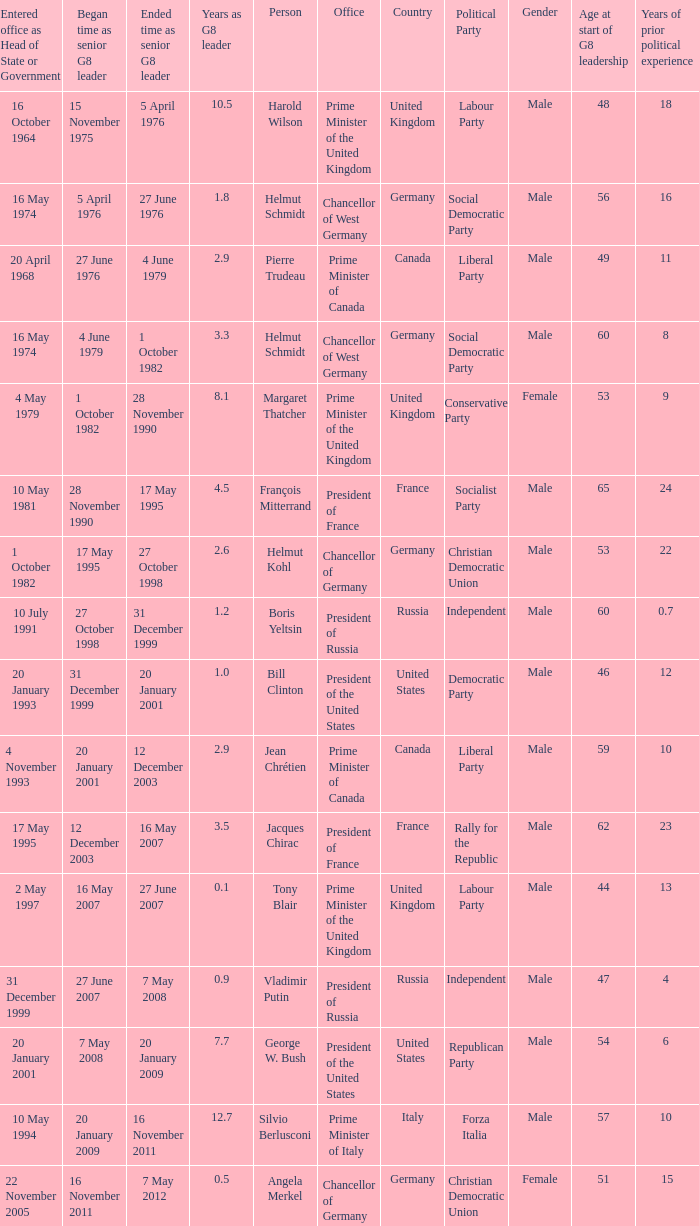When did the Prime Minister of Italy take office? 10 May 1994. Give me the full table as a dictionary. {'header': ['Entered office as Head of State or Government', 'Began time as senior G8 leader', 'Ended time as senior G8 leader', 'Years as G8 leader', 'Person', 'Office', 'Country', 'Political Party', 'Gender', 'Age at start of G8 leadership', 'Years of prior political experience '], 'rows': [['16 October 1964', '15 November 1975', '5 April 1976', '10.5', 'Harold Wilson', 'Prime Minister of the United Kingdom', 'United Kingdom', 'Labour Party', 'Male', '48', '18 '], ['16 May 1974', '5 April 1976', '27 June 1976', '1.8', 'Helmut Schmidt', 'Chancellor of West Germany', 'Germany', 'Social Democratic Party', 'Male', '56', '16 '], ['20 April 1968', '27 June 1976', '4 June 1979', '2.9', 'Pierre Trudeau', 'Prime Minister of Canada', 'Canada', 'Liberal Party', 'Male', '49', '11 '], ['16 May 1974', '4 June 1979', '1 October 1982', '3.3', 'Helmut Schmidt', 'Chancellor of West Germany', 'Germany', 'Social Democratic Party', 'Male', '60', '8 '], ['4 May 1979', '1 October 1982', '28 November 1990', '8.1', 'Margaret Thatcher', 'Prime Minister of the United Kingdom', 'United Kingdom', 'Conservative Party', 'Female', '53', '9 '], ['10 May 1981', '28 November 1990', '17 May 1995', '4.5', 'François Mitterrand', 'President of France', 'France', 'Socialist Party', 'Male', '65', '24 '], ['1 October 1982', '17 May 1995', '27 October 1998', '2.6', 'Helmut Kohl', 'Chancellor of Germany', 'Germany', 'Christian Democratic Union', 'Male', '53', '22 '], ['10 July 1991', '27 October 1998', '31 December 1999', '1.2', 'Boris Yeltsin', 'President of Russia', 'Russia', 'Independent', 'Male', '60', '0.7 '], ['20 January 1993', '31 December 1999', '20 January 2001', '1.0', 'Bill Clinton', 'President of the United States', 'United States', 'Democratic Party', 'Male', '46', '12 '], ['4 November 1993', '20 January 2001', '12 December 2003', '2.9', 'Jean Chrétien', 'Prime Minister of Canada', 'Canada', 'Liberal Party', 'Male', '59', '10 '], ['17 May 1995', '12 December 2003', '16 May 2007', '3.5', 'Jacques Chirac', 'President of France', 'France', 'Rally for the Republic', 'Male', '62', '23 '], ['2 May 1997', '16 May 2007', '27 June 2007', '0.1', 'Tony Blair', 'Prime Minister of the United Kingdom', 'United Kingdom', 'Labour Party', 'Male', '44', '13 '], ['31 December 1999', '27 June 2007', '7 May 2008', '0.9', 'Vladimir Putin', 'President of Russia', 'Russia', 'Independent', 'Male', '47', '4 '], ['20 January 2001', '7 May 2008', '20 January 2009', '7.7', 'George W. Bush', 'President of the United States', 'United States', 'Republican Party', 'Male', '54', '6 '], ['10 May 1994', '20 January 2009', '16 November 2011', '12.7', 'Silvio Berlusconi', 'Prime Minister of Italy', 'Italy', 'Forza Italia', 'Male', '57', '10 '], ['22 November 2005', '16 November 2011', '7 May 2012', '0.5', 'Angela Merkel', 'Chancellor of Germany', 'Germany', 'Christian Democratic Union', 'Female', '51', '15']]} 